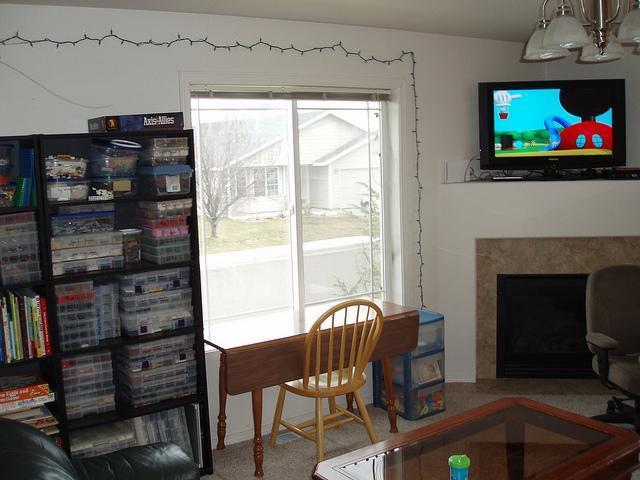How many screens are on?
Give a very brief answer. 1. How many chairs can be seen?
Give a very brief answer. 2. How many birds is the man holding?
Give a very brief answer. 0. 